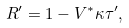Convert formula to latex. <formula><loc_0><loc_0><loc_500><loc_500>R ^ { \prime } = 1 - V ^ { * } \kappa \tau ^ { \prime } ,</formula> 